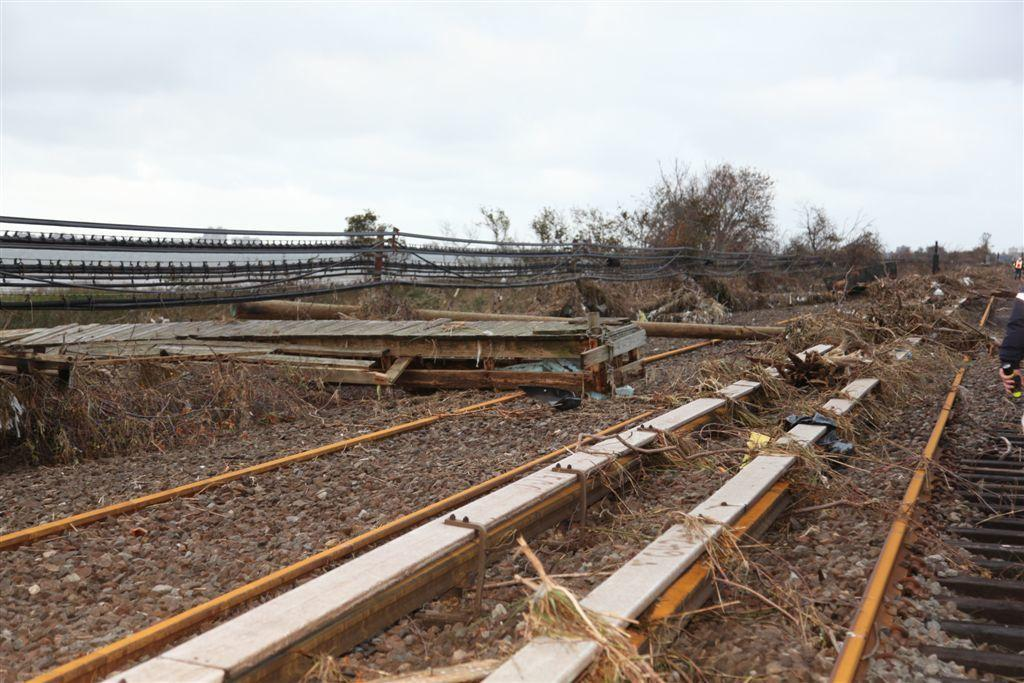What is located at the bottom of the image? There is a railway track at the bottom of the image. What can be seen in the image besides the railway track? There is a fencing in the image. What type of natural environment is visible in the background of the image? There are trees in the background of the image. What is visible at the top of the image? The sky is visible at the top of the image. Can you see a ghost playing basketball with a badge in the image? No, there is no ghost, basketball, or badge present in the image. 